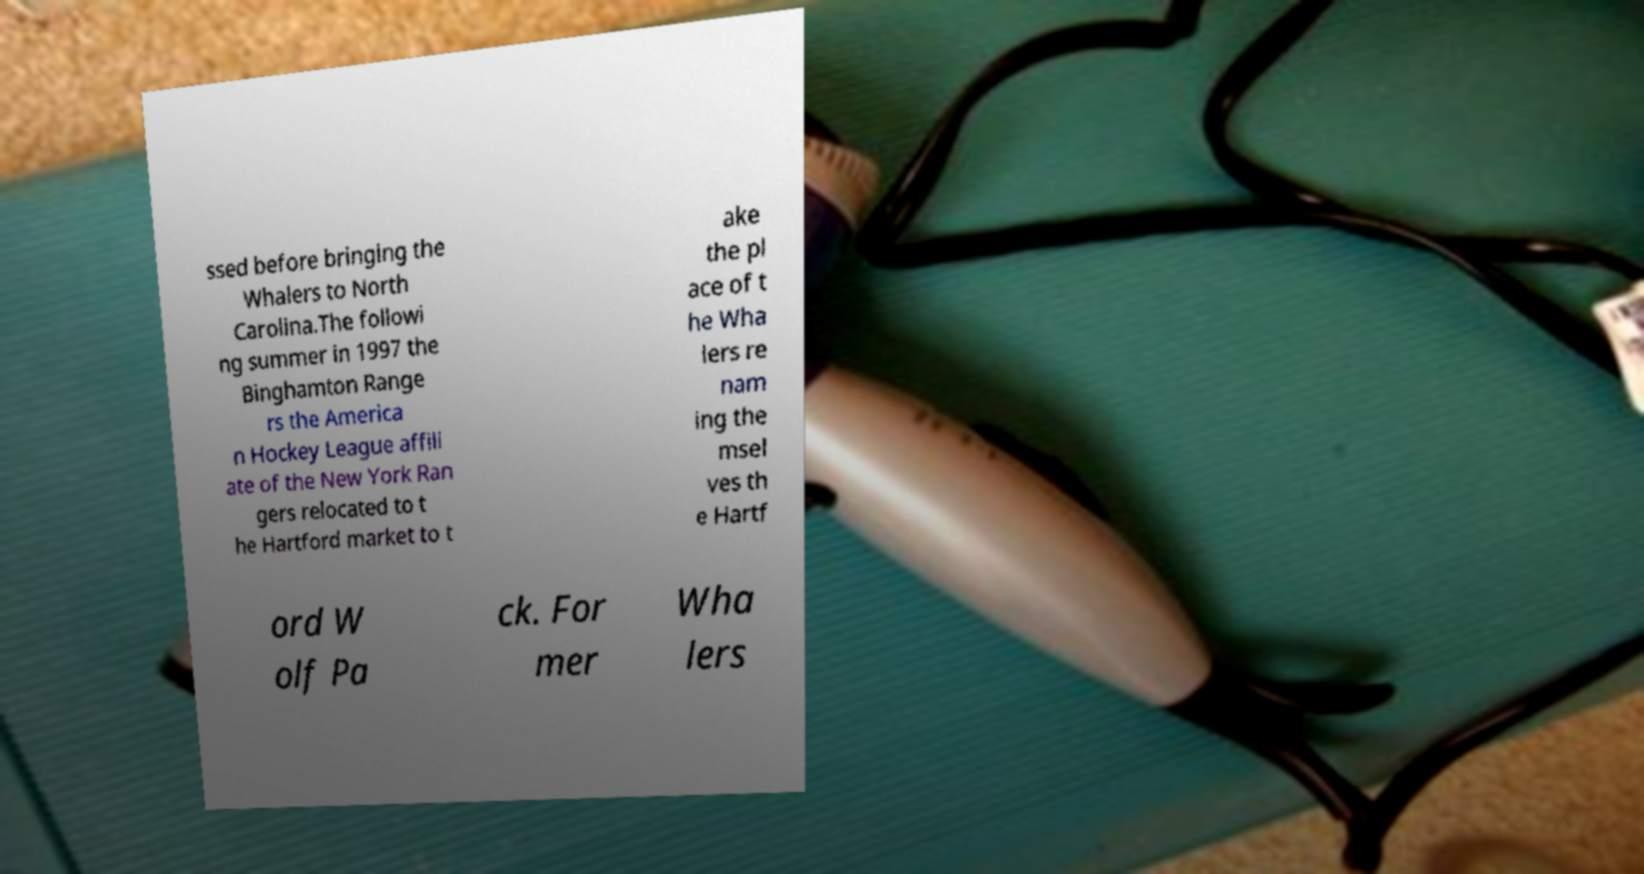Could you assist in decoding the text presented in this image and type it out clearly? ssed before bringing the Whalers to North Carolina.The followi ng summer in 1997 the Binghamton Range rs the America n Hockey League affili ate of the New York Ran gers relocated to t he Hartford market to t ake the pl ace of t he Wha lers re nam ing the msel ves th e Hartf ord W olf Pa ck. For mer Wha lers 